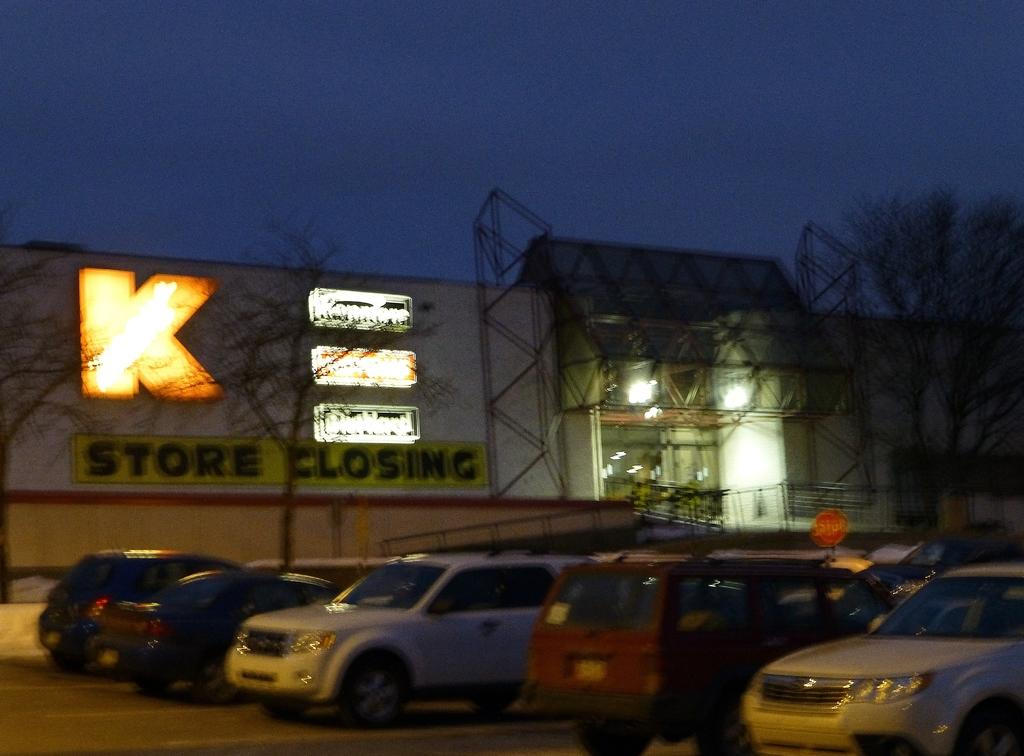<image>
Write a terse but informative summary of the picture. A parking lot in front of K-Mart with a sign for store closing. 